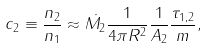<formula> <loc_0><loc_0><loc_500><loc_500>c _ { 2 } \equiv \frac { n _ { 2 } } { n _ { 1 } } \approx \dot { M _ { 2 } } \frac { 1 } { 4 \pi R ^ { 2 } } \frac { 1 } { A _ { 2 } } \frac { \tau _ { 1 , 2 } } { m } ,</formula> 